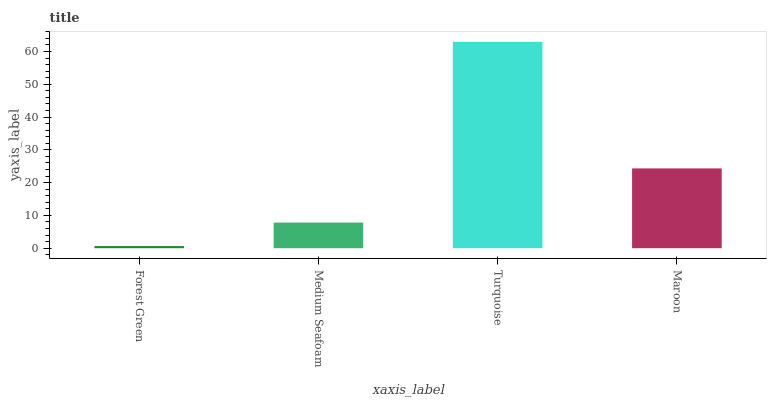Is Forest Green the minimum?
Answer yes or no. Yes. Is Turquoise the maximum?
Answer yes or no. Yes. Is Medium Seafoam the minimum?
Answer yes or no. No. Is Medium Seafoam the maximum?
Answer yes or no. No. Is Medium Seafoam greater than Forest Green?
Answer yes or no. Yes. Is Forest Green less than Medium Seafoam?
Answer yes or no. Yes. Is Forest Green greater than Medium Seafoam?
Answer yes or no. No. Is Medium Seafoam less than Forest Green?
Answer yes or no. No. Is Maroon the high median?
Answer yes or no. Yes. Is Medium Seafoam the low median?
Answer yes or no. Yes. Is Turquoise the high median?
Answer yes or no. No. Is Forest Green the low median?
Answer yes or no. No. 